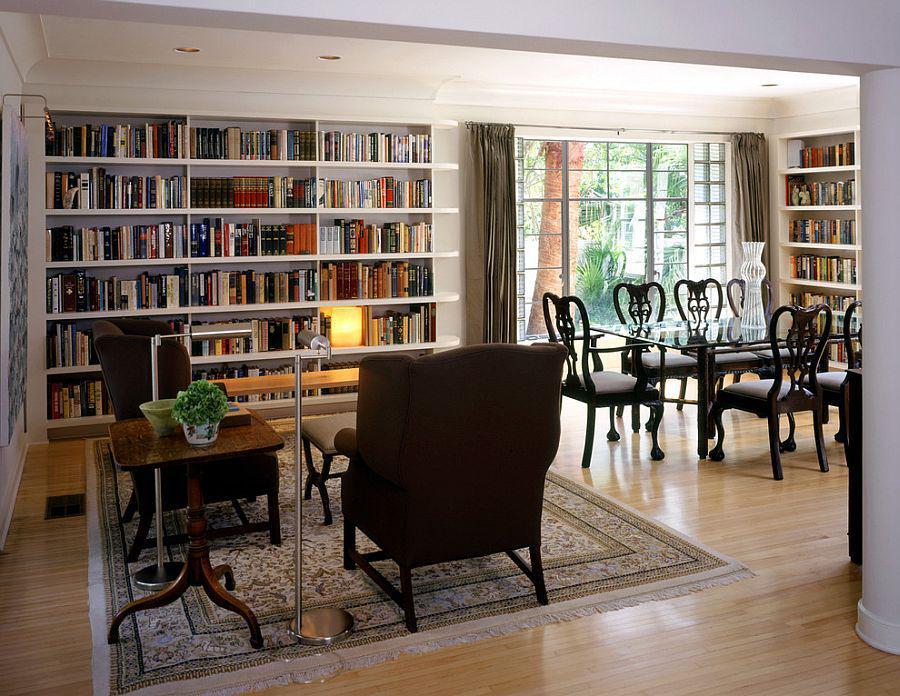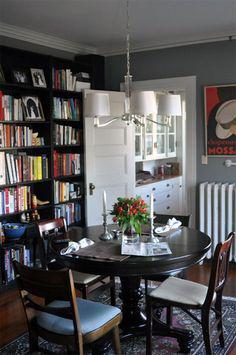The first image is the image on the left, the second image is the image on the right. Considering the images on both sides, is "In one image, a round dining table with chairs and centerpiece is located near large bookshelves." valid? Answer yes or no. Yes. The first image is the image on the left, the second image is the image on the right. Examine the images to the left and right. Is the description "There are chairs with white seats." accurate? Answer yes or no. Yes. 